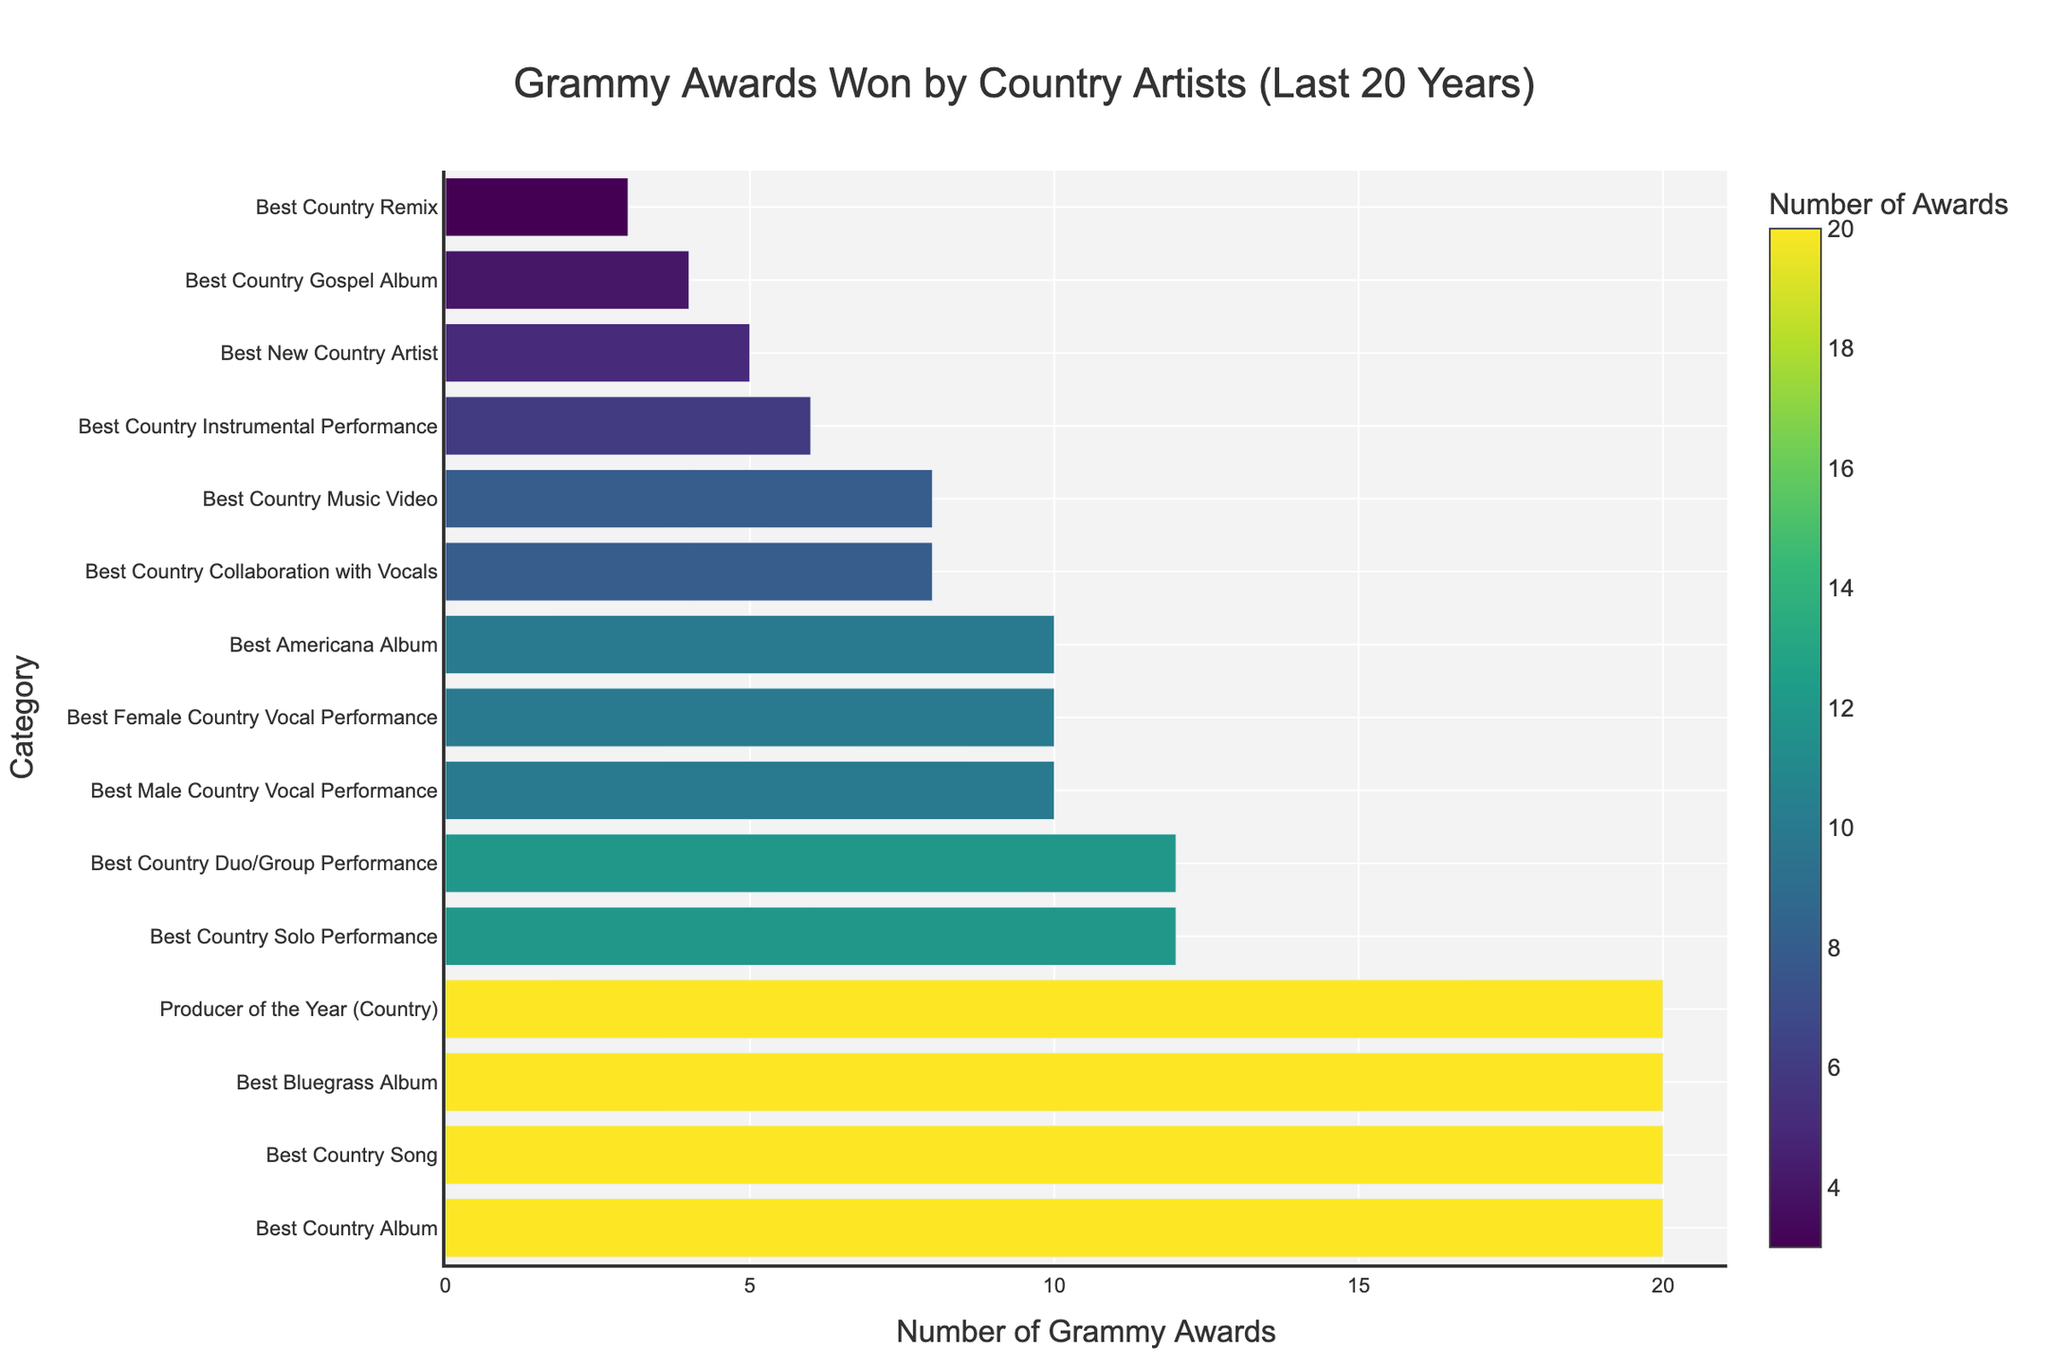What category has the highest number of Grammy awards won by country artists? The category with the longest bar, which also has the furthest distance from the origin on the x-axis, represents the highest number of awards. From the figure, both "Best Country Album", "Best Country Song", "Best Bluegrass Album" and "Producer of the Year (Country)" have the longest bars.
Answer: Best Country Album, Best Country Song, Best Bluegrass Album, Producer of the Year (Country) How many Grammy awards were won for "Best Country Solo Performance" and "Best Country Duo/Group Performance" combined? The number of Grammy awards for "Best Country Solo Performance" is 12, and for "Best Country Duo/Group Performance" is also 12. Adding these together results in \(12 + 12\).
Answer: 24 Which category has more awards: "Best Male Country Vocal Performance" or "Best Female Country Vocal Performance"? By comparing the length of the bars and the numbers on the x-axis, both "Best Male Country Vocal Performance" and "Best Female Country Vocal Performance" have 10 awards each.
Answer: They are equal What is the total number of Grammy awards won for categories related to vocal performances (Male, Female, and Collaboration)? Adding the relevant categories: Best Male Country Vocal Performance (10), Best Female Country Vocal Performance (10), and Best Country Collaboration with Vocals (8), gives the total \(10 + 10 + 8\).
Answer: 28 Which category has fewer awards than "Best Americana Album"? The bar for "Best Americana Album" shows 10 awards. Categories with bars shorter than this include "Best Country Instrumental Performance", "Best New Country Artist", "Best Country Gospel Album", and "Best Country Remix".
Answer: Best Country Instrumental Performance, Best New Country Artist, Best Country Gospel Album, Best Country Remix What's the difference in the number of awards between "Best Country Album" and "Best New Country Artist"? "Best Country Album" has 20 awards, while "Best New Country Artist" has 5 awards. The difference can be found by calculating \(20 - 5\).
Answer: 15 Which category has the second-highest number of Grammy awards? The longest bars correspond to the categories with the highest number of awards. From the figure, "Best Country Album", "Best Country Song", "Best Bluegrass Album" and "Producer of the Year (Country)" all tie for the highest number of awards, making them all the highest and second highest.
Answer: Best Country Album, Best Country Song, Best Bluegrass Album, Producer of the Year (Country) What awards fall within the middle range of total awards received (more than 5 but fewer than 15)? The bars representing categories with more than 5 and fewer than 15 awards include: Best Country Solo Performance (12), Best Country Duo/Group Performance (12), Best Male Country Vocal Performance (10), Best Female Country Vocal Performance (10), Best Americana Album (10), and Best Country Music Video (8).
Answer: Best Country Solo Performance, Best Country Duo/Group Performance, Best Male Country Vocal Performance, Best Female Country Vocal Performance, Best Americana Album, Best Country Music Video Which category related to video content has received Grammy awards and how many? The bar for "Best Country Music Video" represents awards given for video content. This category has 8 awards.
Answer: Best Country Music Video, 8 What is the visual pattern in the bar color for the top three categories? The color gradient in the figure changes based on the number of awards, with more awards represented by lighter colors within the chosen colorscale. The top three categories ("Best Country Album", "Best Country Song", "Best Bluegrass Album", "Producer of the Year (Country)") have the same bright yellow, indicating the maximum number of awards depicted.
Answer: Bright yellow bars representing 20 awards 